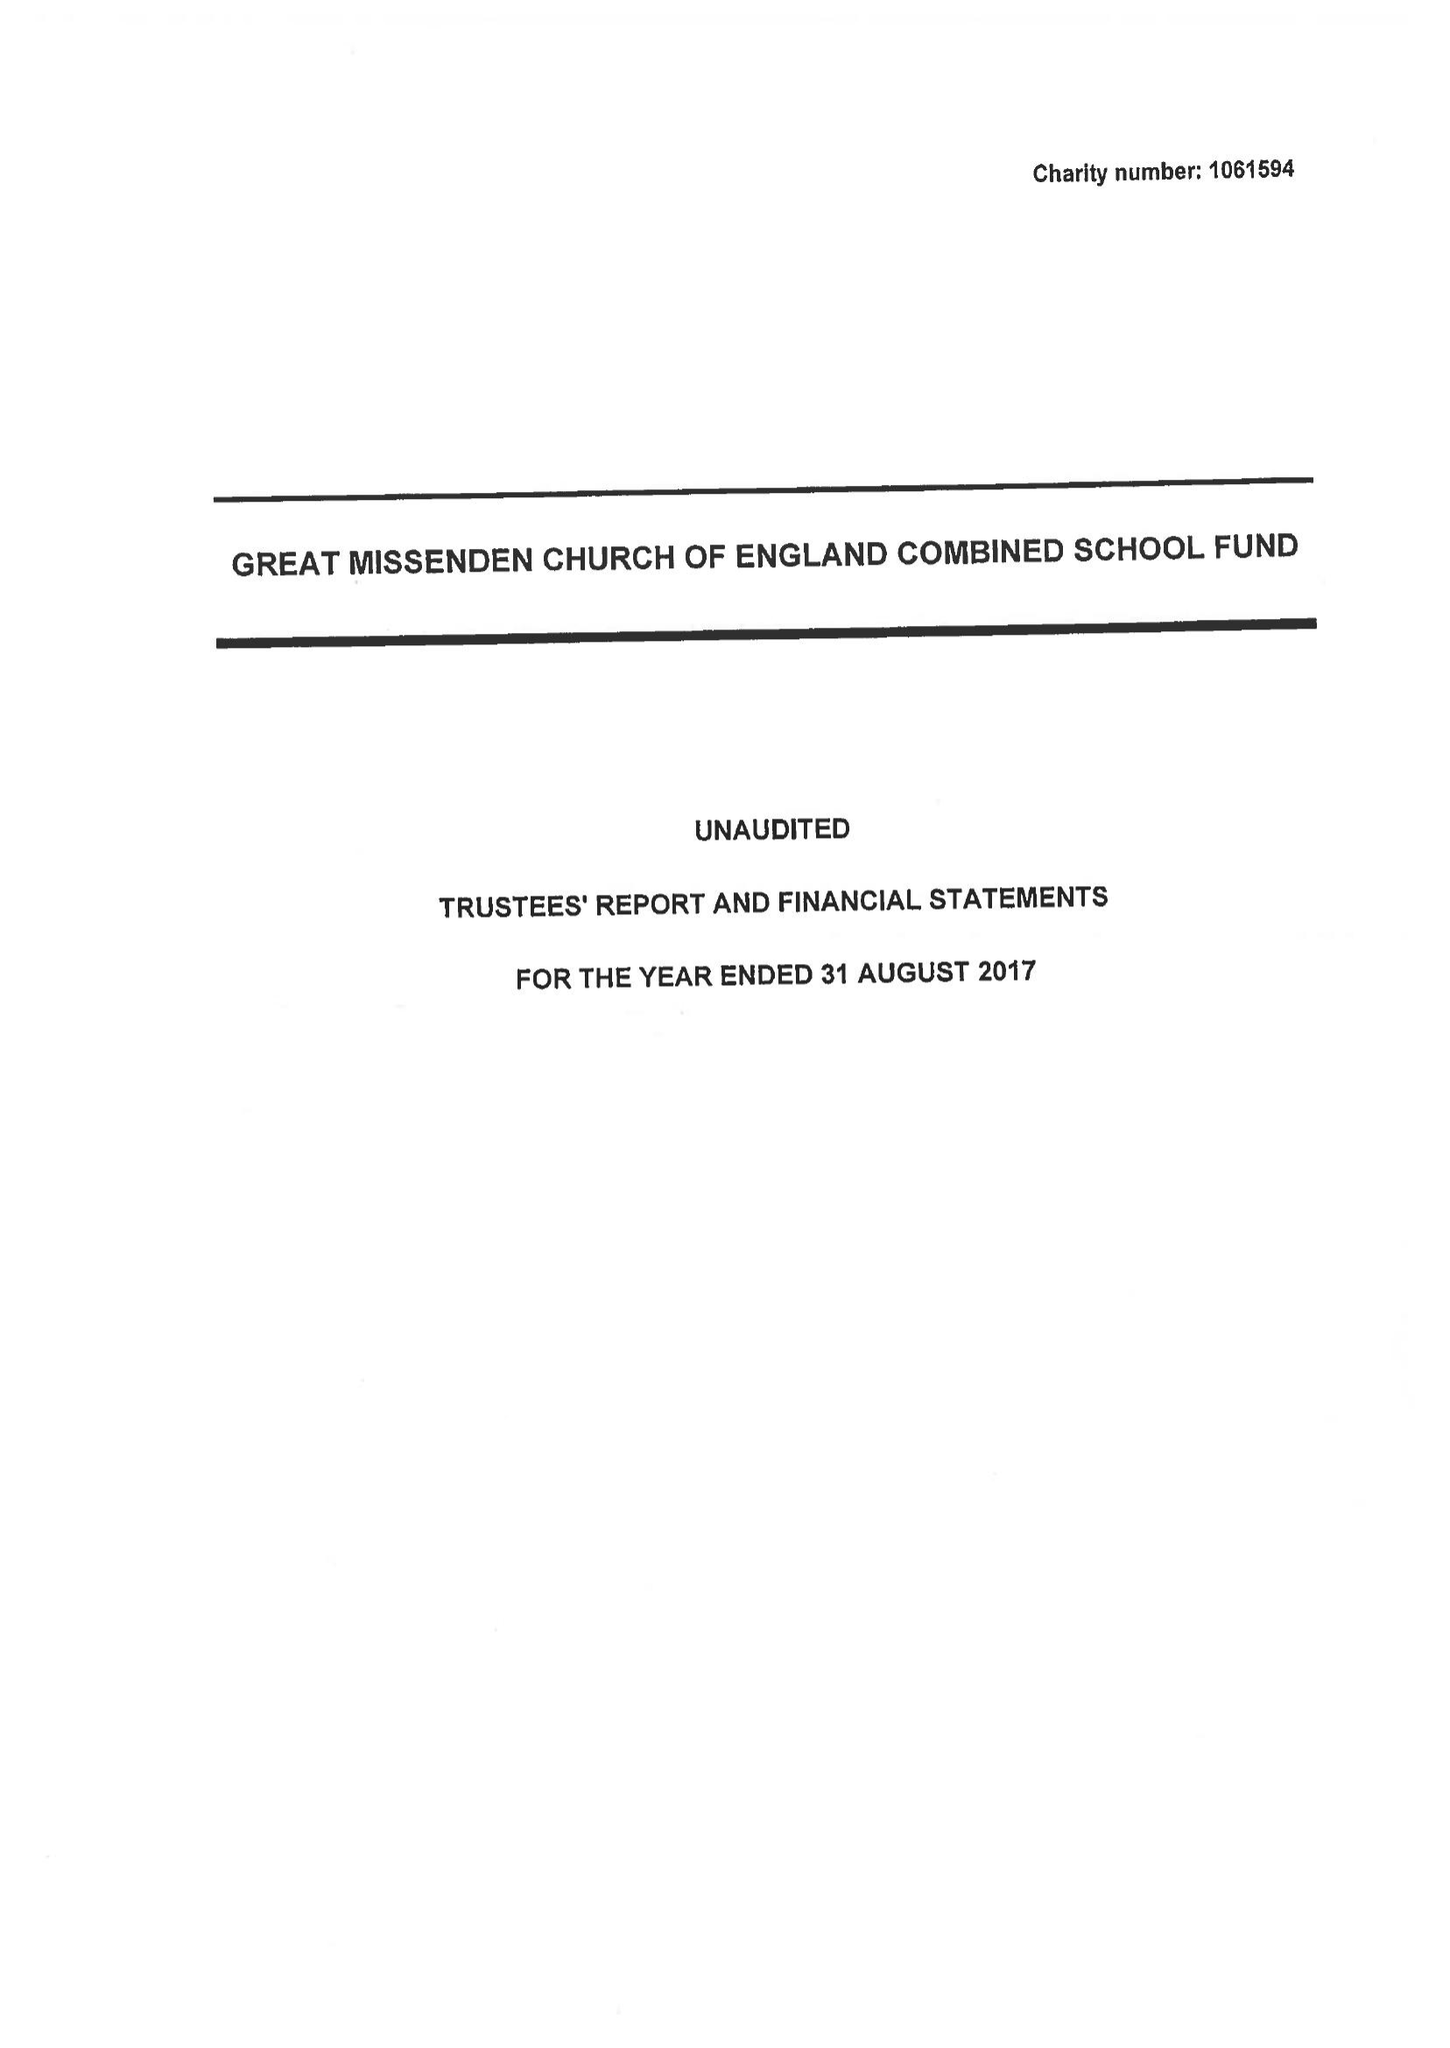What is the value for the charity_number?
Answer the question using a single word or phrase. 1061594 